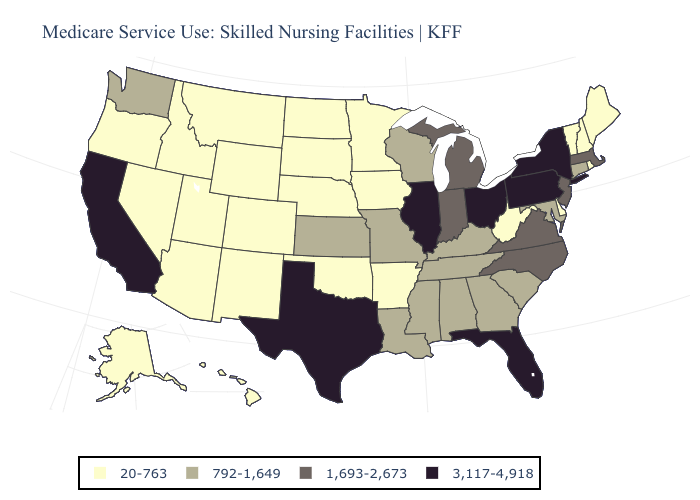Which states have the lowest value in the USA?
Keep it brief. Alaska, Arizona, Arkansas, Colorado, Delaware, Hawaii, Idaho, Iowa, Maine, Minnesota, Montana, Nebraska, Nevada, New Hampshire, New Mexico, North Dakota, Oklahoma, Oregon, Rhode Island, South Dakota, Utah, Vermont, West Virginia, Wyoming. How many symbols are there in the legend?
Short answer required. 4. Name the states that have a value in the range 1,693-2,673?
Quick response, please. Indiana, Massachusetts, Michigan, New Jersey, North Carolina, Virginia. What is the lowest value in the USA?
Give a very brief answer. 20-763. What is the highest value in the West ?
Write a very short answer. 3,117-4,918. Does North Carolina have a lower value than Illinois?
Short answer required. Yes. Does South Carolina have a lower value than Pennsylvania?
Be succinct. Yes. Which states have the lowest value in the USA?
Write a very short answer. Alaska, Arizona, Arkansas, Colorado, Delaware, Hawaii, Idaho, Iowa, Maine, Minnesota, Montana, Nebraska, Nevada, New Hampshire, New Mexico, North Dakota, Oklahoma, Oregon, Rhode Island, South Dakota, Utah, Vermont, West Virginia, Wyoming. Does the map have missing data?
Write a very short answer. No. Among the states that border Montana , which have the highest value?
Be succinct. Idaho, North Dakota, South Dakota, Wyoming. How many symbols are there in the legend?
Quick response, please. 4. Name the states that have a value in the range 792-1,649?
Be succinct. Alabama, Connecticut, Georgia, Kansas, Kentucky, Louisiana, Maryland, Mississippi, Missouri, South Carolina, Tennessee, Washington, Wisconsin. Does the first symbol in the legend represent the smallest category?
Give a very brief answer. Yes. What is the highest value in states that border North Carolina?
Answer briefly. 1,693-2,673. Which states have the lowest value in the Northeast?
Give a very brief answer. Maine, New Hampshire, Rhode Island, Vermont. 